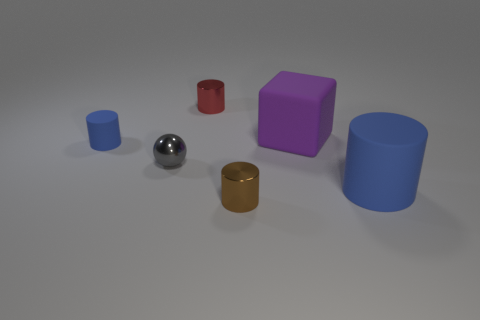Subtract all brown cylinders. How many cylinders are left? 3 Subtract all purple cylinders. Subtract all green cubes. How many cylinders are left? 4 Add 3 cubes. How many objects exist? 9 Subtract all cubes. How many objects are left? 5 Add 5 big yellow spheres. How many big yellow spheres exist? 5 Subtract 0 cyan spheres. How many objects are left? 6 Subtract all large cylinders. Subtract all large purple spheres. How many objects are left? 5 Add 1 tiny matte objects. How many tiny matte objects are left? 2 